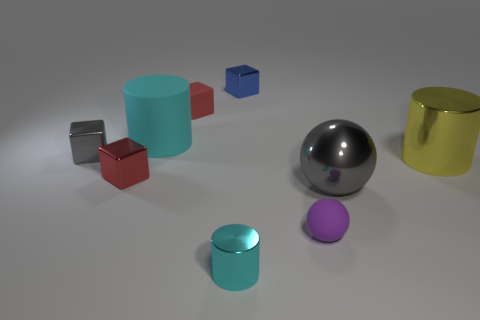What is the shape of the gray metal object that is in front of the gray shiny object on the left side of the blue metallic thing?
Your answer should be very brief. Sphere. What is the color of the small rubber thing that is behind the cyan rubber thing?
Provide a short and direct response. Red. There is a gray sphere that is made of the same material as the tiny cylinder; what size is it?
Your answer should be compact. Large. There is a rubber thing that is the same shape as the yellow metallic thing; what size is it?
Ensure brevity in your answer.  Large. Is there a large gray cylinder?
Provide a succinct answer. No. What number of things are gray shiny things in front of the tiny gray shiny cube or big things?
Offer a terse response. 3. What is the material of the cyan thing that is the same size as the yellow cylinder?
Keep it short and to the point. Rubber. What color is the shiny cube that is in front of the gray thing that is to the left of the small red rubber object?
Ensure brevity in your answer.  Red. There is a blue shiny cube; what number of small objects are in front of it?
Keep it short and to the point. 5. What color is the big matte object?
Your response must be concise. Cyan. 